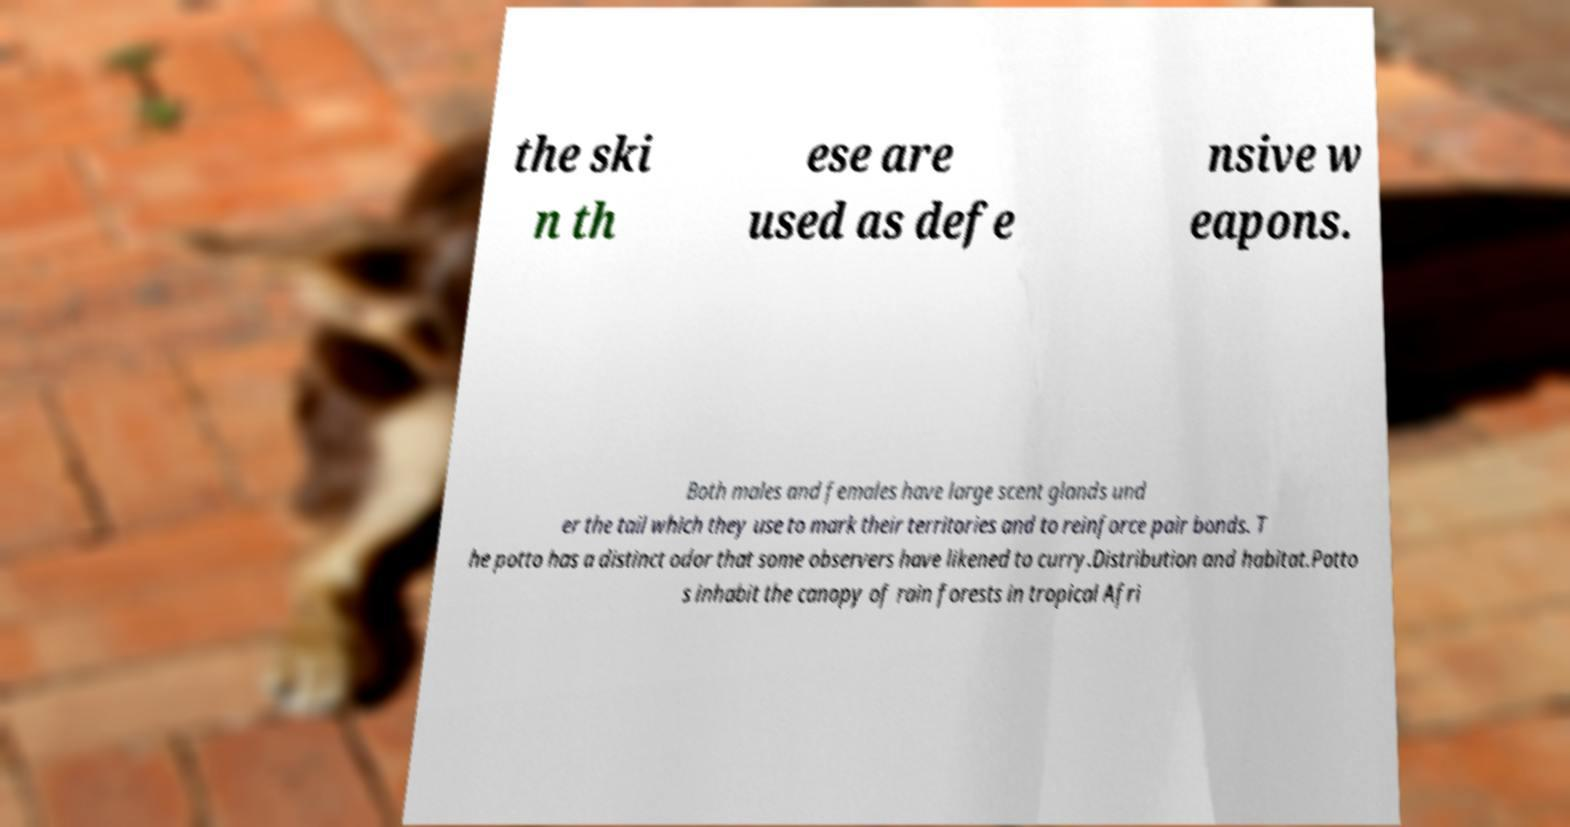For documentation purposes, I need the text within this image transcribed. Could you provide that? the ski n th ese are used as defe nsive w eapons. Both males and females have large scent glands und er the tail which they use to mark their territories and to reinforce pair bonds. T he potto has a distinct odor that some observers have likened to curry.Distribution and habitat.Potto s inhabit the canopy of rain forests in tropical Afri 